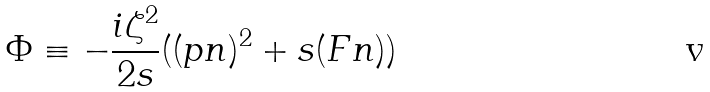Convert formula to latex. <formula><loc_0><loc_0><loc_500><loc_500>\Phi \equiv - \frac { i \zeta ^ { 2 } } { 2 s } ( ( p n ) ^ { 2 } + s ( F n ) )</formula> 